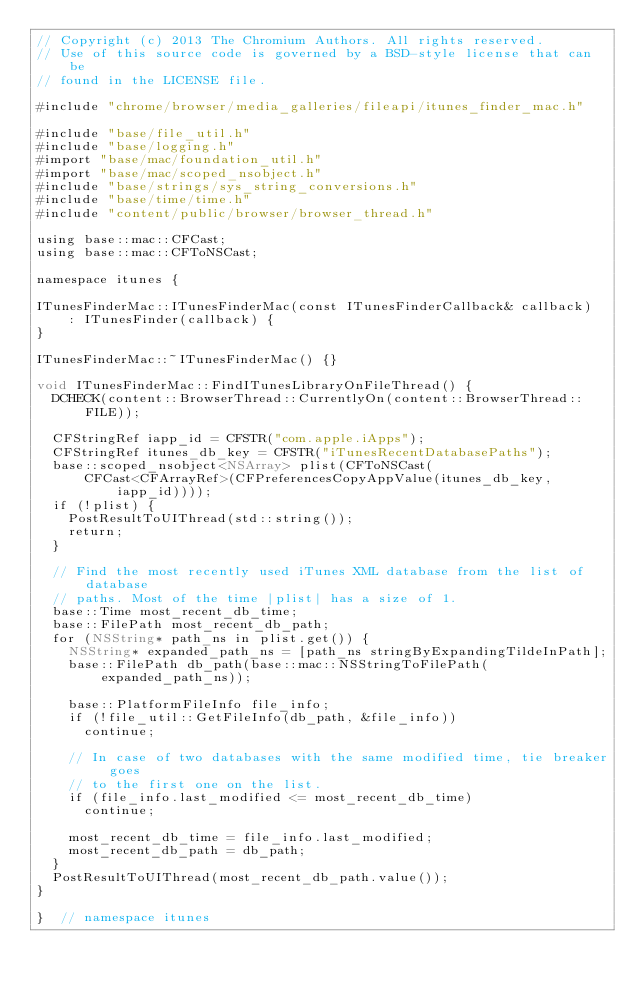<code> <loc_0><loc_0><loc_500><loc_500><_ObjectiveC_>// Copyright (c) 2013 The Chromium Authors. All rights reserved.
// Use of this source code is governed by a BSD-style license that can be
// found in the LICENSE file.

#include "chrome/browser/media_galleries/fileapi/itunes_finder_mac.h"

#include "base/file_util.h"
#include "base/logging.h"
#import "base/mac/foundation_util.h"
#import "base/mac/scoped_nsobject.h"
#include "base/strings/sys_string_conversions.h"
#include "base/time/time.h"
#include "content/public/browser/browser_thread.h"

using base::mac::CFCast;
using base::mac::CFToNSCast;

namespace itunes {

ITunesFinderMac::ITunesFinderMac(const ITunesFinderCallback& callback)
    : ITunesFinder(callback) {
}

ITunesFinderMac::~ITunesFinderMac() {}

void ITunesFinderMac::FindITunesLibraryOnFileThread() {
  DCHECK(content::BrowserThread::CurrentlyOn(content::BrowserThread::FILE));

  CFStringRef iapp_id = CFSTR("com.apple.iApps");
  CFStringRef itunes_db_key = CFSTR("iTunesRecentDatabasePaths");
  base::scoped_nsobject<NSArray> plist(CFToNSCast(
      CFCast<CFArrayRef>(CFPreferencesCopyAppValue(itunes_db_key, iapp_id))));
  if (!plist) {
    PostResultToUIThread(std::string());
    return;
  }

  // Find the most recently used iTunes XML database from the list of database
  // paths. Most of the time |plist| has a size of 1.
  base::Time most_recent_db_time;
  base::FilePath most_recent_db_path;
  for (NSString* path_ns in plist.get()) {
    NSString* expanded_path_ns = [path_ns stringByExpandingTildeInPath];
    base::FilePath db_path(base::mac::NSStringToFilePath(expanded_path_ns));

    base::PlatformFileInfo file_info;
    if (!file_util::GetFileInfo(db_path, &file_info))
      continue;

    // In case of two databases with the same modified time, tie breaker goes
    // to the first one on the list.
    if (file_info.last_modified <= most_recent_db_time)
      continue;

    most_recent_db_time = file_info.last_modified;
    most_recent_db_path = db_path;
  }
  PostResultToUIThread(most_recent_db_path.value());
}

}  // namespace itunes
</code> 